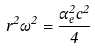<formula> <loc_0><loc_0><loc_500><loc_500>r ^ { 2 } \omega ^ { 2 } = \frac { \alpha _ { e } ^ { 2 } c ^ { 2 } } { 4 }</formula> 